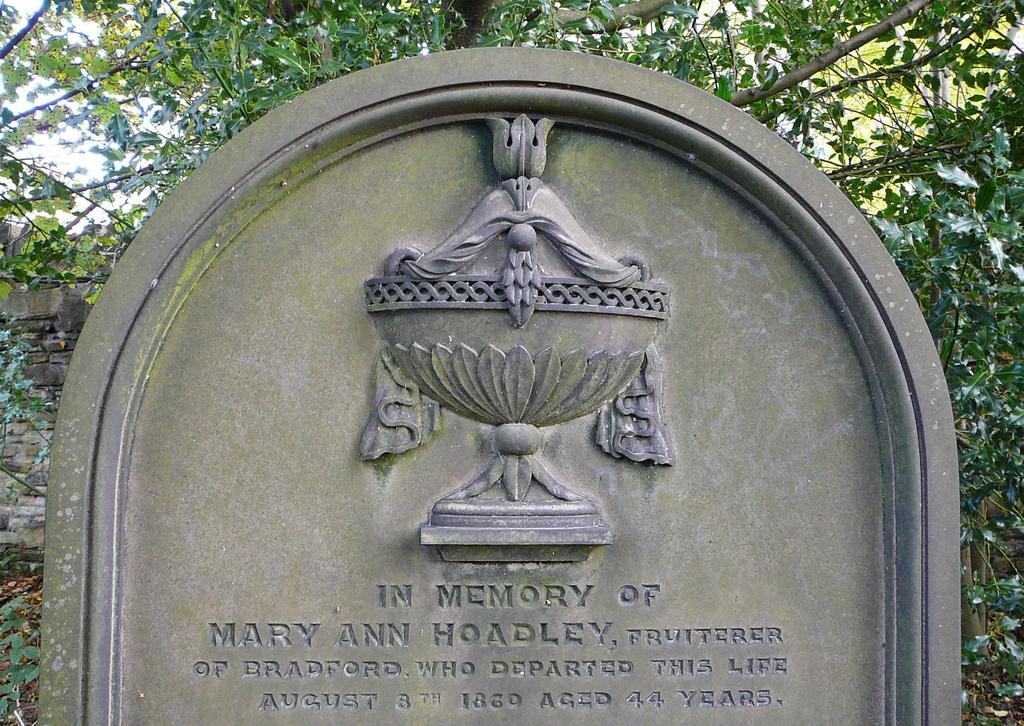What is the main subject in the foreground of the picture? There is a memorial rock in the foreground of the picture. What can be seen on the left side of the picture? There is a wall on the left side of the picture. What type of natural elements are visible in the background of the picture? There are trees visible in the background of the picture. Who is the creator of the ducks seen in the picture? There are no ducks present in the image, so it is not possible to determine who their creator might be. 